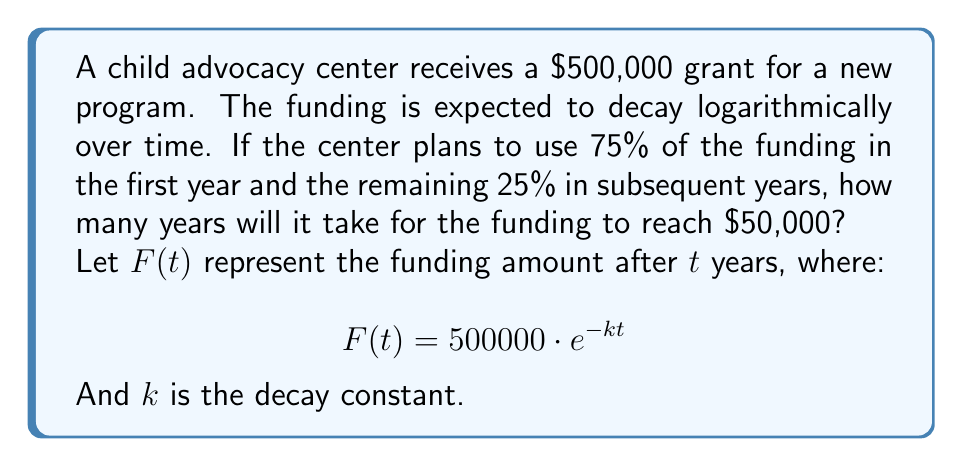Can you answer this question? 1. First, we need to find the decay constant $k$ using the information that 75% of the funding is used in the first year:

   $F(1) = 0.25 \cdot 500000 = 125000$
   
   $125000 = 500000 \cdot e^{-k \cdot 1}$
   
   $0.25 = e^{-k}$
   
   $\ln(0.25) = -k$
   
   $k = -\ln(0.25) \approx 1.3863$

2. Now we can use this $k$ value in our equation to find when $F(t) = 50000$:

   $50000 = 500000 \cdot e^{-1.3863t}$
   
   $0.1 = e^{-1.3863t}$
   
   $\ln(0.1) = -1.3863t$
   
   $t = \frac{\ln(0.1)}{-1.3863}$

3. Solving for $t$:

   $t = \frac{\ln(0.1)}{-1.3863} \approx 1.6609$

4. Rounding up to the nearest year (as we can't have a partial year in this context):

   $t = 2$ years
Answer: 2 years 